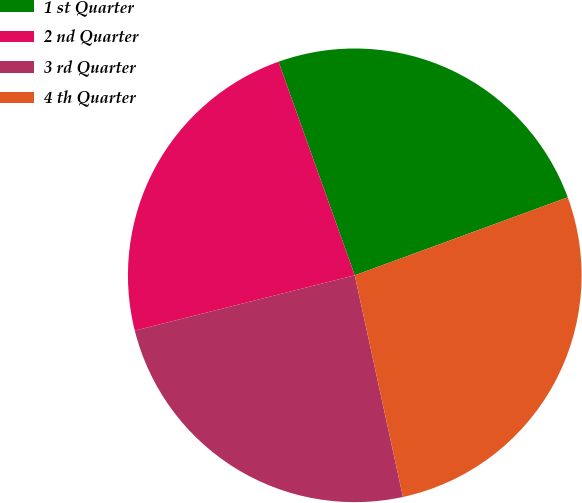<chart> <loc_0><loc_0><loc_500><loc_500><pie_chart><fcel>1 st Quarter<fcel>2 nd Quarter<fcel>3 rd Quarter<fcel>4 th Quarter<nl><fcel>24.87%<fcel>23.46%<fcel>24.49%<fcel>27.18%<nl></chart> 